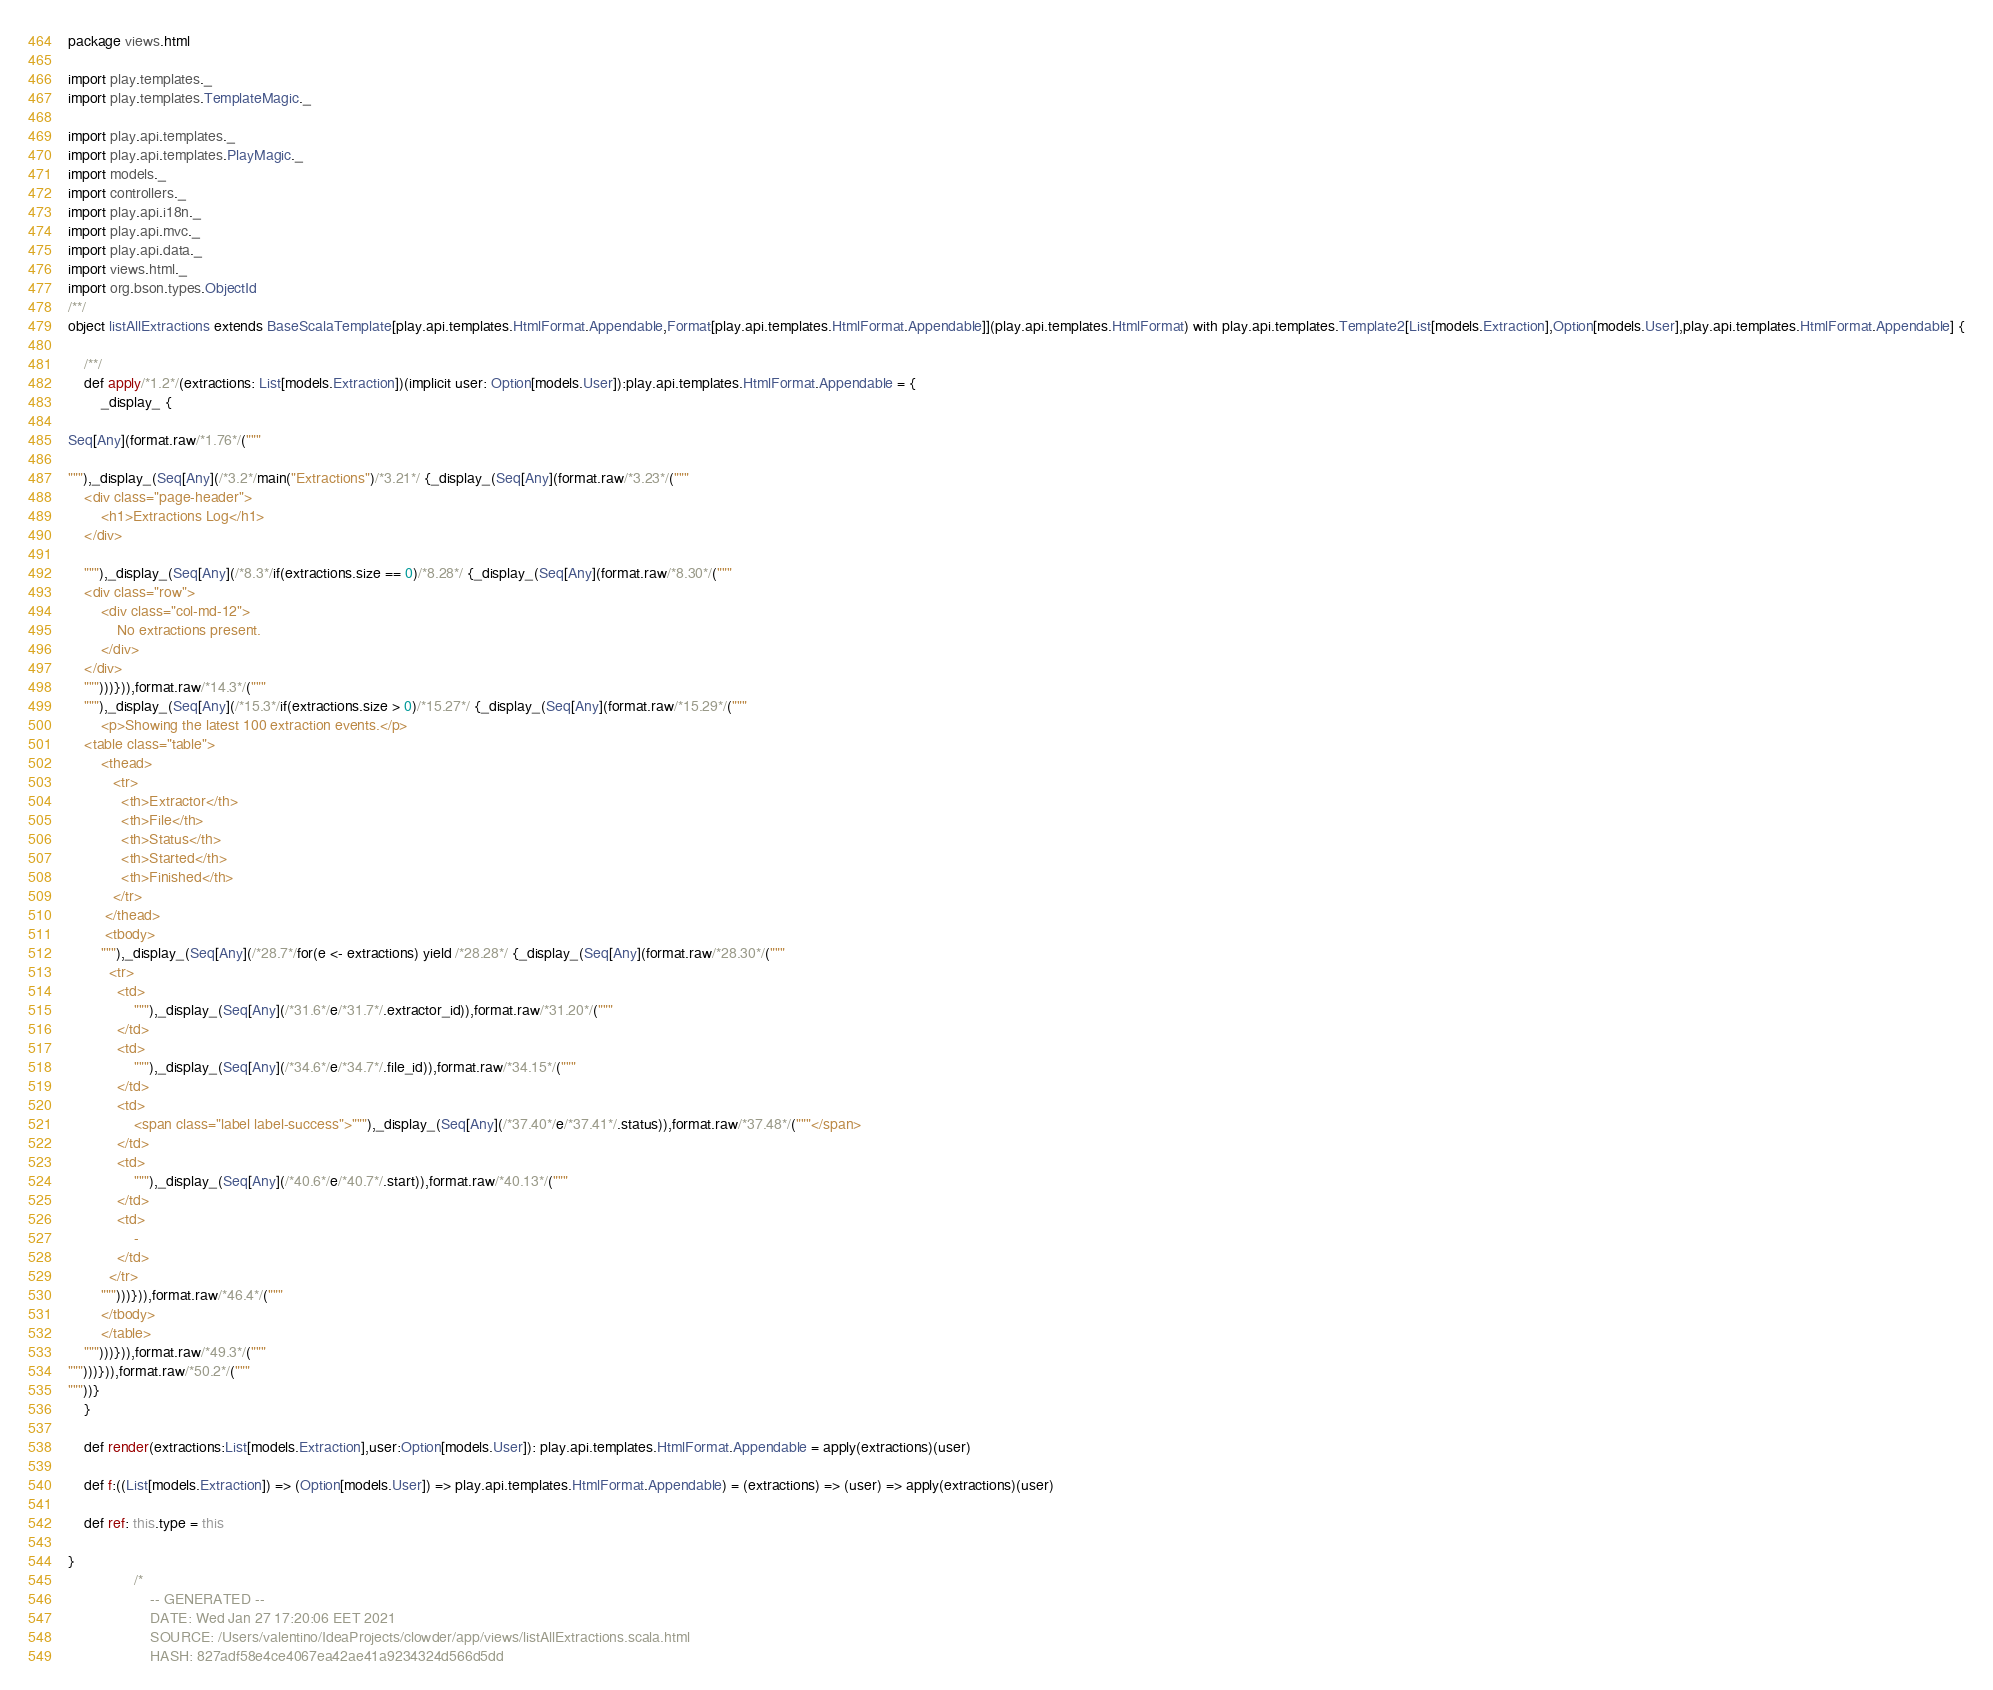Convert code to text. <code><loc_0><loc_0><loc_500><loc_500><_Scala_>
package views.html

import play.templates._
import play.templates.TemplateMagic._

import play.api.templates._
import play.api.templates.PlayMagic._
import models._
import controllers._
import play.api.i18n._
import play.api.mvc._
import play.api.data._
import views.html._
import org.bson.types.ObjectId
/**/
object listAllExtractions extends BaseScalaTemplate[play.api.templates.HtmlFormat.Appendable,Format[play.api.templates.HtmlFormat.Appendable]](play.api.templates.HtmlFormat) with play.api.templates.Template2[List[models.Extraction],Option[models.User],play.api.templates.HtmlFormat.Appendable] {

    /**/
    def apply/*1.2*/(extractions: List[models.Extraction])(implicit user: Option[models.User]):play.api.templates.HtmlFormat.Appendable = {
        _display_ {

Seq[Any](format.raw/*1.76*/("""

"""),_display_(Seq[Any](/*3.2*/main("Extractions")/*3.21*/ {_display_(Seq[Any](format.raw/*3.23*/("""
	<div class="page-header">
		<h1>Extractions Log</h1>
	</div>
	
	"""),_display_(Seq[Any](/*8.3*/if(extractions.size == 0)/*8.28*/ {_display_(Seq[Any](format.raw/*8.30*/("""
	<div class="row">
		<div class="col-md-12">
			No extractions present.
		</div>
	</div>
	""")))})),format.raw/*14.3*/("""
	"""),_display_(Seq[Any](/*15.3*/if(extractions.size > 0)/*15.27*/ {_display_(Seq[Any](format.raw/*15.29*/("""
		<p>Showing the latest 100 extraction events.</p>
	<table class="table">
		<thead>
	       <tr>
	         <th>Extractor</th>
	         <th>File</th>
	         <th>Status</th>
	         <th>Started</th>
	         <th>Finished</th>
	       </tr>
	     </thead>
	     <tbody>
	    """),_display_(Seq[Any](/*28.7*/for(e <- extractions) yield /*28.28*/ {_display_(Seq[Any](format.raw/*28.30*/("""
	      <tr>
			<td>
				"""),_display_(Seq[Any](/*31.6*/e/*31.7*/.extractor_id)),format.raw/*31.20*/("""
			</td>
			<td>
				"""),_display_(Seq[Any](/*34.6*/e/*34.7*/.file_id)),format.raw/*34.15*/("""
			</td>
			<td>
				<span class="label label-success">"""),_display_(Seq[Any](/*37.40*/e/*37.41*/.status)),format.raw/*37.48*/("""</span>
			</td>
			<td>
				"""),_display_(Seq[Any](/*40.6*/e/*40.7*/.start)),format.raw/*40.13*/("""
			</td>
			<td>
				-
			</td>
		  </tr>
		""")))})),format.raw/*46.4*/("""
		</tbody>
		</table>
	""")))})),format.raw/*49.3*/("""
""")))})),format.raw/*50.2*/("""
"""))}
    }
    
    def render(extractions:List[models.Extraction],user:Option[models.User]): play.api.templates.HtmlFormat.Appendable = apply(extractions)(user)
    
    def f:((List[models.Extraction]) => (Option[models.User]) => play.api.templates.HtmlFormat.Appendable) = (extractions) => (user) => apply(extractions)(user)
    
    def ref: this.type = this

}
                /*
                    -- GENERATED --
                    DATE: Wed Jan 27 17:20:06 EET 2021
                    SOURCE: /Users/valentino/IdeaProjects/clowder/app/views/listAllExtractions.scala.html
                    HASH: 827adf58e4ce4067ea42ae41a9234324d566d5dd</code> 